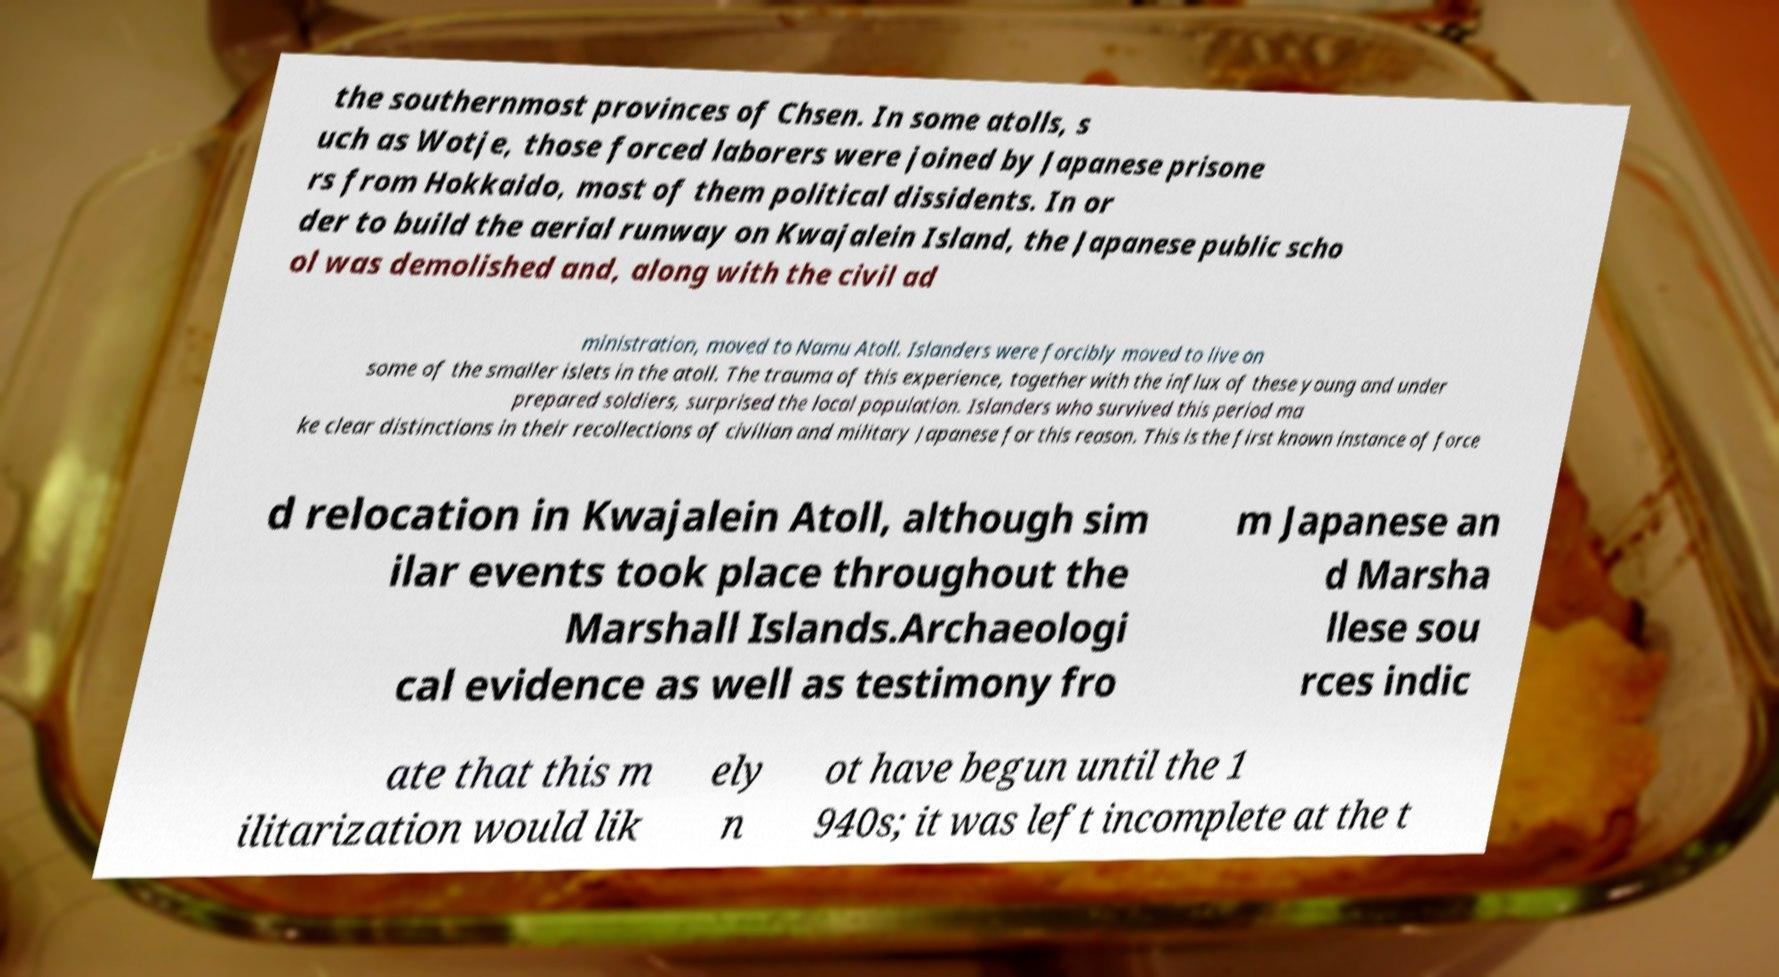For documentation purposes, I need the text within this image transcribed. Could you provide that? the southernmost provinces of Chsen. In some atolls, s uch as Wotje, those forced laborers were joined by Japanese prisone rs from Hokkaido, most of them political dissidents. In or der to build the aerial runway on Kwajalein Island, the Japanese public scho ol was demolished and, along with the civil ad ministration, moved to Namu Atoll. Islanders were forcibly moved to live on some of the smaller islets in the atoll. The trauma of this experience, together with the influx of these young and under prepared soldiers, surprised the local population. Islanders who survived this period ma ke clear distinctions in their recollections of civilian and military Japanese for this reason. This is the first known instance of force d relocation in Kwajalein Atoll, although sim ilar events took place throughout the Marshall Islands.Archaeologi cal evidence as well as testimony fro m Japanese an d Marsha llese sou rces indic ate that this m ilitarization would lik ely n ot have begun until the 1 940s; it was left incomplete at the t 